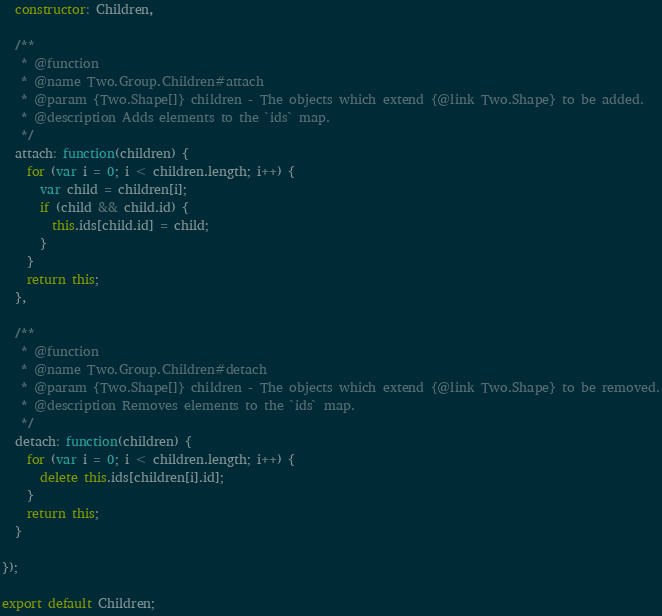Convert code to text. <code><loc_0><loc_0><loc_500><loc_500><_JavaScript_>
  constructor: Children,

  /**
   * @function
   * @name Two.Group.Children#attach
   * @param {Two.Shape[]} children - The objects which extend {@link Two.Shape} to be added.
   * @description Adds elements to the `ids` map.
   */
  attach: function(children) {
    for (var i = 0; i < children.length; i++) {
      var child = children[i];
      if (child && child.id) {
        this.ids[child.id] = child;
      }
    }
    return this;
  },

  /**
   * @function
   * @name Two.Group.Children#detach
   * @param {Two.Shape[]} children - The objects which extend {@link Two.Shape} to be removed.
   * @description Removes elements to the `ids` map.
   */
  detach: function(children) {
    for (var i = 0; i < children.length; i++) {
      delete this.ids[children[i].id];
    }
    return this;
  }

});

export default Children;
</code> 